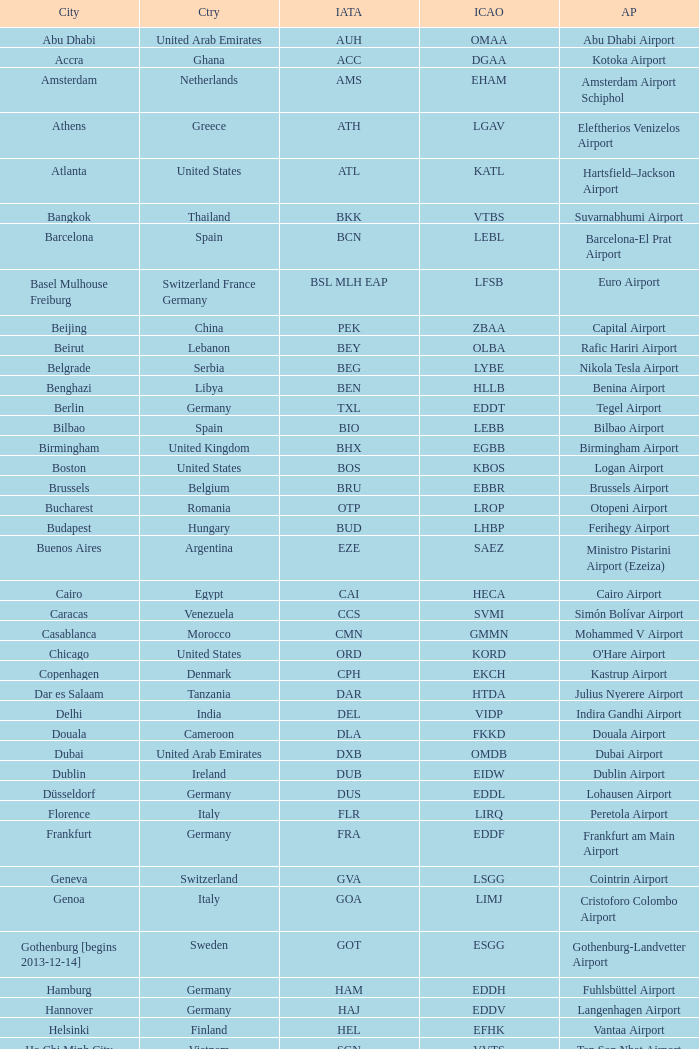Which city has the IATA SSG? Malabo. 